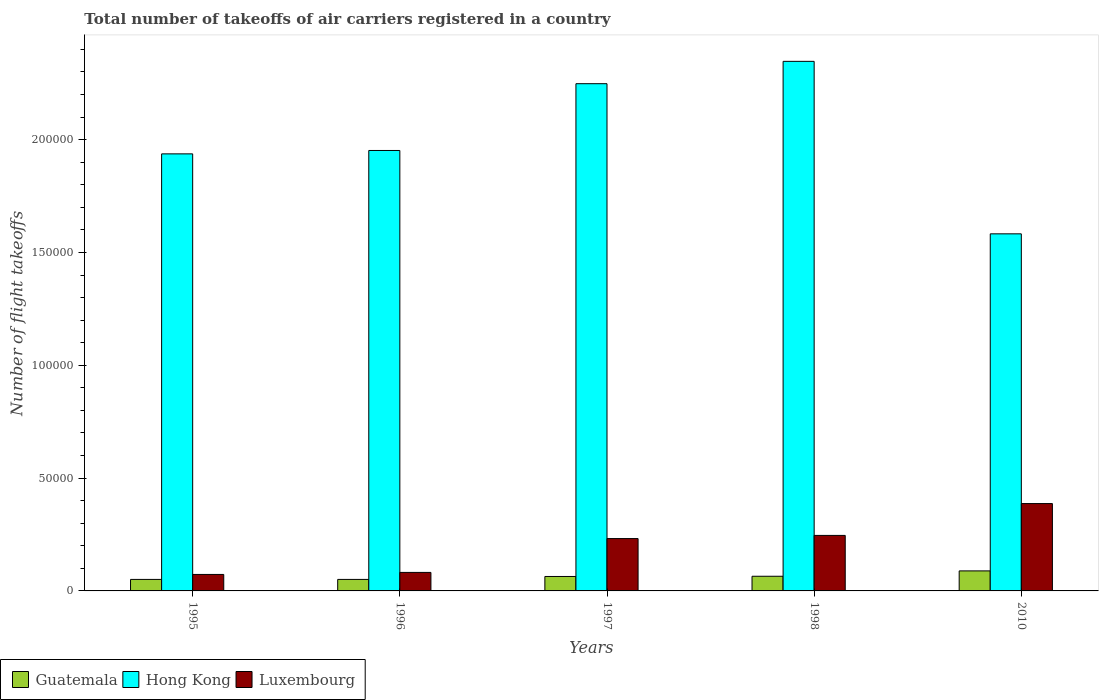How many different coloured bars are there?
Provide a short and direct response. 3. Are the number of bars per tick equal to the number of legend labels?
Provide a succinct answer. Yes. Are the number of bars on each tick of the X-axis equal?
Your answer should be compact. Yes. How many bars are there on the 3rd tick from the left?
Provide a succinct answer. 3. In how many cases, is the number of bars for a given year not equal to the number of legend labels?
Your answer should be very brief. 0. What is the total number of flight takeoffs in Luxembourg in 2010?
Your answer should be very brief. 3.87e+04. Across all years, what is the maximum total number of flight takeoffs in Luxembourg?
Your response must be concise. 3.87e+04. Across all years, what is the minimum total number of flight takeoffs in Hong Kong?
Make the answer very short. 1.58e+05. In which year was the total number of flight takeoffs in Luxembourg maximum?
Offer a terse response. 2010. In which year was the total number of flight takeoffs in Hong Kong minimum?
Your answer should be very brief. 2010. What is the total total number of flight takeoffs in Guatemala in the graph?
Make the answer very short. 3.20e+04. What is the difference between the total number of flight takeoffs in Luxembourg in 1995 and that in 1998?
Provide a succinct answer. -1.73e+04. What is the difference between the total number of flight takeoffs in Hong Kong in 2010 and the total number of flight takeoffs in Luxembourg in 1996?
Offer a very short reply. 1.50e+05. What is the average total number of flight takeoffs in Luxembourg per year?
Make the answer very short. 2.04e+04. In the year 1995, what is the difference between the total number of flight takeoffs in Luxembourg and total number of flight takeoffs in Hong Kong?
Make the answer very short. -1.86e+05. In how many years, is the total number of flight takeoffs in Guatemala greater than 10000?
Ensure brevity in your answer.  0. What is the ratio of the total number of flight takeoffs in Luxembourg in 1995 to that in 2010?
Provide a succinct answer. 0.19. Is the total number of flight takeoffs in Hong Kong in 1996 less than that in 1998?
Offer a terse response. Yes. What is the difference between the highest and the second highest total number of flight takeoffs in Luxembourg?
Make the answer very short. 1.41e+04. What is the difference between the highest and the lowest total number of flight takeoffs in Guatemala?
Make the answer very short. 3775. Is the sum of the total number of flight takeoffs in Hong Kong in 1995 and 1996 greater than the maximum total number of flight takeoffs in Luxembourg across all years?
Ensure brevity in your answer.  Yes. What does the 1st bar from the left in 2010 represents?
Offer a very short reply. Guatemala. What does the 3rd bar from the right in 1996 represents?
Make the answer very short. Guatemala. How many years are there in the graph?
Give a very brief answer. 5. Does the graph contain any zero values?
Your answer should be compact. No. Where does the legend appear in the graph?
Give a very brief answer. Bottom left. How many legend labels are there?
Ensure brevity in your answer.  3. What is the title of the graph?
Your response must be concise. Total number of takeoffs of air carriers registered in a country. What is the label or title of the Y-axis?
Make the answer very short. Number of flight takeoffs. What is the Number of flight takeoffs in Guatemala in 1995?
Provide a succinct answer. 5100. What is the Number of flight takeoffs in Hong Kong in 1995?
Offer a terse response. 1.94e+05. What is the Number of flight takeoffs in Luxembourg in 1995?
Your answer should be very brief. 7300. What is the Number of flight takeoffs of Guatemala in 1996?
Offer a terse response. 5100. What is the Number of flight takeoffs in Hong Kong in 1996?
Offer a very short reply. 1.95e+05. What is the Number of flight takeoffs in Luxembourg in 1996?
Make the answer very short. 8200. What is the Number of flight takeoffs in Guatemala in 1997?
Keep it short and to the point. 6400. What is the Number of flight takeoffs of Hong Kong in 1997?
Provide a succinct answer. 2.25e+05. What is the Number of flight takeoffs of Luxembourg in 1997?
Your response must be concise. 2.32e+04. What is the Number of flight takeoffs in Guatemala in 1998?
Make the answer very short. 6500. What is the Number of flight takeoffs in Hong Kong in 1998?
Provide a succinct answer. 2.35e+05. What is the Number of flight takeoffs in Luxembourg in 1998?
Keep it short and to the point. 2.46e+04. What is the Number of flight takeoffs of Guatemala in 2010?
Offer a very short reply. 8875. What is the Number of flight takeoffs in Hong Kong in 2010?
Offer a very short reply. 1.58e+05. What is the Number of flight takeoffs of Luxembourg in 2010?
Your answer should be very brief. 3.87e+04. Across all years, what is the maximum Number of flight takeoffs in Guatemala?
Keep it short and to the point. 8875. Across all years, what is the maximum Number of flight takeoffs in Hong Kong?
Keep it short and to the point. 2.35e+05. Across all years, what is the maximum Number of flight takeoffs of Luxembourg?
Offer a very short reply. 3.87e+04. Across all years, what is the minimum Number of flight takeoffs in Guatemala?
Provide a succinct answer. 5100. Across all years, what is the minimum Number of flight takeoffs of Hong Kong?
Ensure brevity in your answer.  1.58e+05. Across all years, what is the minimum Number of flight takeoffs of Luxembourg?
Give a very brief answer. 7300. What is the total Number of flight takeoffs of Guatemala in the graph?
Provide a short and direct response. 3.20e+04. What is the total Number of flight takeoffs in Hong Kong in the graph?
Offer a terse response. 1.01e+06. What is the total Number of flight takeoffs in Luxembourg in the graph?
Your answer should be compact. 1.02e+05. What is the difference between the Number of flight takeoffs of Guatemala in 1995 and that in 1996?
Provide a succinct answer. 0. What is the difference between the Number of flight takeoffs in Hong Kong in 1995 and that in 1996?
Offer a very short reply. -1500. What is the difference between the Number of flight takeoffs of Luxembourg in 1995 and that in 1996?
Give a very brief answer. -900. What is the difference between the Number of flight takeoffs of Guatemala in 1995 and that in 1997?
Provide a succinct answer. -1300. What is the difference between the Number of flight takeoffs of Hong Kong in 1995 and that in 1997?
Your answer should be very brief. -3.11e+04. What is the difference between the Number of flight takeoffs in Luxembourg in 1995 and that in 1997?
Ensure brevity in your answer.  -1.59e+04. What is the difference between the Number of flight takeoffs of Guatemala in 1995 and that in 1998?
Give a very brief answer. -1400. What is the difference between the Number of flight takeoffs of Hong Kong in 1995 and that in 1998?
Offer a very short reply. -4.10e+04. What is the difference between the Number of flight takeoffs of Luxembourg in 1995 and that in 1998?
Ensure brevity in your answer.  -1.73e+04. What is the difference between the Number of flight takeoffs of Guatemala in 1995 and that in 2010?
Your answer should be very brief. -3775. What is the difference between the Number of flight takeoffs of Hong Kong in 1995 and that in 2010?
Ensure brevity in your answer.  3.54e+04. What is the difference between the Number of flight takeoffs in Luxembourg in 1995 and that in 2010?
Ensure brevity in your answer.  -3.14e+04. What is the difference between the Number of flight takeoffs of Guatemala in 1996 and that in 1997?
Provide a succinct answer. -1300. What is the difference between the Number of flight takeoffs of Hong Kong in 1996 and that in 1997?
Keep it short and to the point. -2.96e+04. What is the difference between the Number of flight takeoffs of Luxembourg in 1996 and that in 1997?
Provide a succinct answer. -1.50e+04. What is the difference between the Number of flight takeoffs in Guatemala in 1996 and that in 1998?
Your response must be concise. -1400. What is the difference between the Number of flight takeoffs in Hong Kong in 1996 and that in 1998?
Offer a terse response. -3.95e+04. What is the difference between the Number of flight takeoffs in Luxembourg in 1996 and that in 1998?
Give a very brief answer. -1.64e+04. What is the difference between the Number of flight takeoffs in Guatemala in 1996 and that in 2010?
Provide a succinct answer. -3775. What is the difference between the Number of flight takeoffs in Hong Kong in 1996 and that in 2010?
Offer a terse response. 3.69e+04. What is the difference between the Number of flight takeoffs in Luxembourg in 1996 and that in 2010?
Keep it short and to the point. -3.05e+04. What is the difference between the Number of flight takeoffs of Guatemala in 1997 and that in 1998?
Your answer should be very brief. -100. What is the difference between the Number of flight takeoffs of Hong Kong in 1997 and that in 1998?
Offer a very short reply. -9900. What is the difference between the Number of flight takeoffs in Luxembourg in 1997 and that in 1998?
Provide a succinct answer. -1400. What is the difference between the Number of flight takeoffs of Guatemala in 1997 and that in 2010?
Offer a terse response. -2475. What is the difference between the Number of flight takeoffs in Hong Kong in 1997 and that in 2010?
Provide a succinct answer. 6.65e+04. What is the difference between the Number of flight takeoffs of Luxembourg in 1997 and that in 2010?
Ensure brevity in your answer.  -1.55e+04. What is the difference between the Number of flight takeoffs in Guatemala in 1998 and that in 2010?
Offer a terse response. -2375. What is the difference between the Number of flight takeoffs of Hong Kong in 1998 and that in 2010?
Your answer should be very brief. 7.64e+04. What is the difference between the Number of flight takeoffs in Luxembourg in 1998 and that in 2010?
Your response must be concise. -1.41e+04. What is the difference between the Number of flight takeoffs of Guatemala in 1995 and the Number of flight takeoffs of Hong Kong in 1996?
Keep it short and to the point. -1.90e+05. What is the difference between the Number of flight takeoffs of Guatemala in 1995 and the Number of flight takeoffs of Luxembourg in 1996?
Your answer should be very brief. -3100. What is the difference between the Number of flight takeoffs of Hong Kong in 1995 and the Number of flight takeoffs of Luxembourg in 1996?
Offer a very short reply. 1.86e+05. What is the difference between the Number of flight takeoffs in Guatemala in 1995 and the Number of flight takeoffs in Hong Kong in 1997?
Provide a short and direct response. -2.20e+05. What is the difference between the Number of flight takeoffs of Guatemala in 1995 and the Number of flight takeoffs of Luxembourg in 1997?
Give a very brief answer. -1.81e+04. What is the difference between the Number of flight takeoffs in Hong Kong in 1995 and the Number of flight takeoffs in Luxembourg in 1997?
Ensure brevity in your answer.  1.70e+05. What is the difference between the Number of flight takeoffs of Guatemala in 1995 and the Number of flight takeoffs of Hong Kong in 1998?
Give a very brief answer. -2.30e+05. What is the difference between the Number of flight takeoffs in Guatemala in 1995 and the Number of flight takeoffs in Luxembourg in 1998?
Keep it short and to the point. -1.95e+04. What is the difference between the Number of flight takeoffs of Hong Kong in 1995 and the Number of flight takeoffs of Luxembourg in 1998?
Offer a very short reply. 1.69e+05. What is the difference between the Number of flight takeoffs in Guatemala in 1995 and the Number of flight takeoffs in Hong Kong in 2010?
Make the answer very short. -1.53e+05. What is the difference between the Number of flight takeoffs of Guatemala in 1995 and the Number of flight takeoffs of Luxembourg in 2010?
Ensure brevity in your answer.  -3.36e+04. What is the difference between the Number of flight takeoffs in Hong Kong in 1995 and the Number of flight takeoffs in Luxembourg in 2010?
Provide a succinct answer. 1.55e+05. What is the difference between the Number of flight takeoffs of Guatemala in 1996 and the Number of flight takeoffs of Hong Kong in 1997?
Provide a short and direct response. -2.20e+05. What is the difference between the Number of flight takeoffs of Guatemala in 1996 and the Number of flight takeoffs of Luxembourg in 1997?
Provide a succinct answer. -1.81e+04. What is the difference between the Number of flight takeoffs of Hong Kong in 1996 and the Number of flight takeoffs of Luxembourg in 1997?
Your response must be concise. 1.72e+05. What is the difference between the Number of flight takeoffs of Guatemala in 1996 and the Number of flight takeoffs of Hong Kong in 1998?
Give a very brief answer. -2.30e+05. What is the difference between the Number of flight takeoffs of Guatemala in 1996 and the Number of flight takeoffs of Luxembourg in 1998?
Give a very brief answer. -1.95e+04. What is the difference between the Number of flight takeoffs in Hong Kong in 1996 and the Number of flight takeoffs in Luxembourg in 1998?
Offer a terse response. 1.71e+05. What is the difference between the Number of flight takeoffs in Guatemala in 1996 and the Number of flight takeoffs in Hong Kong in 2010?
Offer a terse response. -1.53e+05. What is the difference between the Number of flight takeoffs of Guatemala in 1996 and the Number of flight takeoffs of Luxembourg in 2010?
Make the answer very short. -3.36e+04. What is the difference between the Number of flight takeoffs in Hong Kong in 1996 and the Number of flight takeoffs in Luxembourg in 2010?
Provide a short and direct response. 1.56e+05. What is the difference between the Number of flight takeoffs in Guatemala in 1997 and the Number of flight takeoffs in Hong Kong in 1998?
Offer a very short reply. -2.28e+05. What is the difference between the Number of flight takeoffs in Guatemala in 1997 and the Number of flight takeoffs in Luxembourg in 1998?
Provide a short and direct response. -1.82e+04. What is the difference between the Number of flight takeoffs of Hong Kong in 1997 and the Number of flight takeoffs of Luxembourg in 1998?
Keep it short and to the point. 2.00e+05. What is the difference between the Number of flight takeoffs of Guatemala in 1997 and the Number of flight takeoffs of Hong Kong in 2010?
Keep it short and to the point. -1.52e+05. What is the difference between the Number of flight takeoffs in Guatemala in 1997 and the Number of flight takeoffs in Luxembourg in 2010?
Provide a short and direct response. -3.23e+04. What is the difference between the Number of flight takeoffs in Hong Kong in 1997 and the Number of flight takeoffs in Luxembourg in 2010?
Make the answer very short. 1.86e+05. What is the difference between the Number of flight takeoffs in Guatemala in 1998 and the Number of flight takeoffs in Hong Kong in 2010?
Your answer should be compact. -1.52e+05. What is the difference between the Number of flight takeoffs in Guatemala in 1998 and the Number of flight takeoffs in Luxembourg in 2010?
Ensure brevity in your answer.  -3.22e+04. What is the difference between the Number of flight takeoffs of Hong Kong in 1998 and the Number of flight takeoffs of Luxembourg in 2010?
Your response must be concise. 1.96e+05. What is the average Number of flight takeoffs in Guatemala per year?
Offer a terse response. 6395. What is the average Number of flight takeoffs in Hong Kong per year?
Offer a very short reply. 2.01e+05. What is the average Number of flight takeoffs of Luxembourg per year?
Your response must be concise. 2.04e+04. In the year 1995, what is the difference between the Number of flight takeoffs in Guatemala and Number of flight takeoffs in Hong Kong?
Provide a short and direct response. -1.89e+05. In the year 1995, what is the difference between the Number of flight takeoffs in Guatemala and Number of flight takeoffs in Luxembourg?
Keep it short and to the point. -2200. In the year 1995, what is the difference between the Number of flight takeoffs of Hong Kong and Number of flight takeoffs of Luxembourg?
Ensure brevity in your answer.  1.86e+05. In the year 1996, what is the difference between the Number of flight takeoffs in Guatemala and Number of flight takeoffs in Hong Kong?
Your response must be concise. -1.90e+05. In the year 1996, what is the difference between the Number of flight takeoffs of Guatemala and Number of flight takeoffs of Luxembourg?
Your answer should be very brief. -3100. In the year 1996, what is the difference between the Number of flight takeoffs of Hong Kong and Number of flight takeoffs of Luxembourg?
Your answer should be compact. 1.87e+05. In the year 1997, what is the difference between the Number of flight takeoffs of Guatemala and Number of flight takeoffs of Hong Kong?
Ensure brevity in your answer.  -2.18e+05. In the year 1997, what is the difference between the Number of flight takeoffs in Guatemala and Number of flight takeoffs in Luxembourg?
Ensure brevity in your answer.  -1.68e+04. In the year 1997, what is the difference between the Number of flight takeoffs in Hong Kong and Number of flight takeoffs in Luxembourg?
Provide a succinct answer. 2.02e+05. In the year 1998, what is the difference between the Number of flight takeoffs of Guatemala and Number of flight takeoffs of Hong Kong?
Keep it short and to the point. -2.28e+05. In the year 1998, what is the difference between the Number of flight takeoffs of Guatemala and Number of flight takeoffs of Luxembourg?
Provide a succinct answer. -1.81e+04. In the year 1998, what is the difference between the Number of flight takeoffs of Hong Kong and Number of flight takeoffs of Luxembourg?
Your answer should be very brief. 2.10e+05. In the year 2010, what is the difference between the Number of flight takeoffs of Guatemala and Number of flight takeoffs of Hong Kong?
Provide a succinct answer. -1.49e+05. In the year 2010, what is the difference between the Number of flight takeoffs of Guatemala and Number of flight takeoffs of Luxembourg?
Make the answer very short. -2.98e+04. In the year 2010, what is the difference between the Number of flight takeoffs in Hong Kong and Number of flight takeoffs in Luxembourg?
Make the answer very short. 1.20e+05. What is the ratio of the Number of flight takeoffs in Guatemala in 1995 to that in 1996?
Ensure brevity in your answer.  1. What is the ratio of the Number of flight takeoffs of Luxembourg in 1995 to that in 1996?
Your answer should be very brief. 0.89. What is the ratio of the Number of flight takeoffs of Guatemala in 1995 to that in 1997?
Give a very brief answer. 0.8. What is the ratio of the Number of flight takeoffs of Hong Kong in 1995 to that in 1997?
Your answer should be compact. 0.86. What is the ratio of the Number of flight takeoffs in Luxembourg in 1995 to that in 1997?
Provide a short and direct response. 0.31. What is the ratio of the Number of flight takeoffs in Guatemala in 1995 to that in 1998?
Your response must be concise. 0.78. What is the ratio of the Number of flight takeoffs of Hong Kong in 1995 to that in 1998?
Your answer should be compact. 0.83. What is the ratio of the Number of flight takeoffs in Luxembourg in 1995 to that in 1998?
Your answer should be compact. 0.3. What is the ratio of the Number of flight takeoffs in Guatemala in 1995 to that in 2010?
Your answer should be compact. 0.57. What is the ratio of the Number of flight takeoffs in Hong Kong in 1995 to that in 2010?
Make the answer very short. 1.22. What is the ratio of the Number of flight takeoffs of Luxembourg in 1995 to that in 2010?
Offer a very short reply. 0.19. What is the ratio of the Number of flight takeoffs in Guatemala in 1996 to that in 1997?
Give a very brief answer. 0.8. What is the ratio of the Number of flight takeoffs in Hong Kong in 1996 to that in 1997?
Your response must be concise. 0.87. What is the ratio of the Number of flight takeoffs of Luxembourg in 1996 to that in 1997?
Provide a short and direct response. 0.35. What is the ratio of the Number of flight takeoffs of Guatemala in 1996 to that in 1998?
Your answer should be compact. 0.78. What is the ratio of the Number of flight takeoffs of Hong Kong in 1996 to that in 1998?
Offer a terse response. 0.83. What is the ratio of the Number of flight takeoffs of Guatemala in 1996 to that in 2010?
Your answer should be compact. 0.57. What is the ratio of the Number of flight takeoffs in Hong Kong in 1996 to that in 2010?
Make the answer very short. 1.23. What is the ratio of the Number of flight takeoffs of Luxembourg in 1996 to that in 2010?
Give a very brief answer. 0.21. What is the ratio of the Number of flight takeoffs of Guatemala in 1997 to that in 1998?
Provide a short and direct response. 0.98. What is the ratio of the Number of flight takeoffs in Hong Kong in 1997 to that in 1998?
Your answer should be very brief. 0.96. What is the ratio of the Number of flight takeoffs of Luxembourg in 1997 to that in 1998?
Make the answer very short. 0.94. What is the ratio of the Number of flight takeoffs in Guatemala in 1997 to that in 2010?
Provide a short and direct response. 0.72. What is the ratio of the Number of flight takeoffs of Hong Kong in 1997 to that in 2010?
Keep it short and to the point. 1.42. What is the ratio of the Number of flight takeoffs of Luxembourg in 1997 to that in 2010?
Ensure brevity in your answer.  0.6. What is the ratio of the Number of flight takeoffs in Guatemala in 1998 to that in 2010?
Your response must be concise. 0.73. What is the ratio of the Number of flight takeoffs of Hong Kong in 1998 to that in 2010?
Your response must be concise. 1.48. What is the ratio of the Number of flight takeoffs of Luxembourg in 1998 to that in 2010?
Keep it short and to the point. 0.64. What is the difference between the highest and the second highest Number of flight takeoffs in Guatemala?
Offer a terse response. 2375. What is the difference between the highest and the second highest Number of flight takeoffs in Hong Kong?
Keep it short and to the point. 9900. What is the difference between the highest and the second highest Number of flight takeoffs in Luxembourg?
Provide a short and direct response. 1.41e+04. What is the difference between the highest and the lowest Number of flight takeoffs of Guatemala?
Make the answer very short. 3775. What is the difference between the highest and the lowest Number of flight takeoffs of Hong Kong?
Provide a succinct answer. 7.64e+04. What is the difference between the highest and the lowest Number of flight takeoffs in Luxembourg?
Your answer should be very brief. 3.14e+04. 